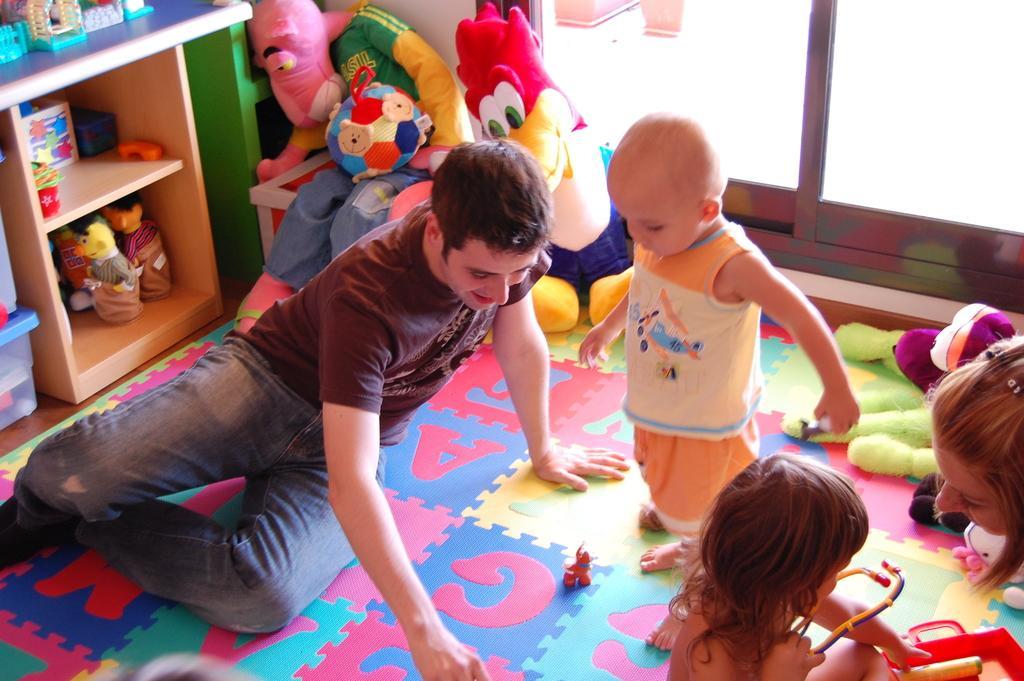Could you give a brief overview of what you see in this image? In this picture I can see a man, a woman and 2 children in front and I see number of soft toys in the background. On the left side of this picture I can see the racks and on the racks, I can see few more toys. I can also see that, the child on the right is holding a thing. 